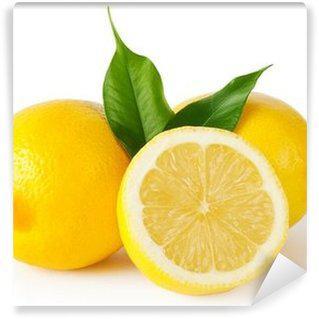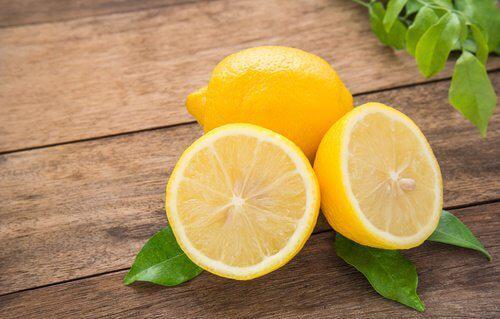The first image is the image on the left, the second image is the image on the right. Evaluate the accuracy of this statement regarding the images: "There are exactly three uncut lemons.". Is it true? Answer yes or no. Yes. The first image is the image on the left, the second image is the image on the right. Considering the images on both sides, is "Each image contains green leaves, lemon half, and whole lemon." valid? Answer yes or no. Yes. 